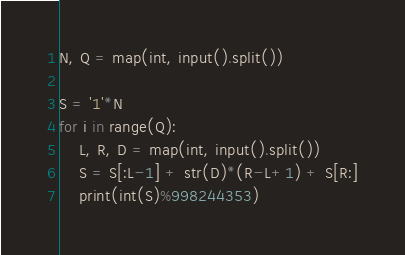Convert code to text. <code><loc_0><loc_0><loc_500><loc_500><_Python_>N, Q = map(int, input().split())

S = '1'*N
for i in range(Q):
    L, R, D = map(int, input().split())
    S = S[:L-1] + str(D)*(R-L+1) + S[R:]
    print(int(S)%998244353)</code> 